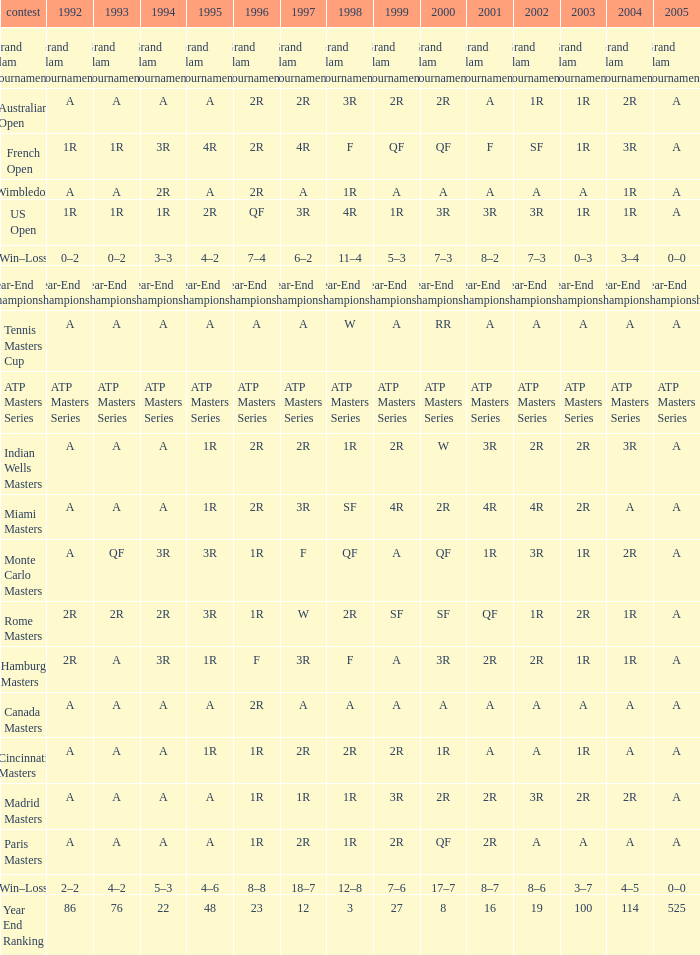Give me the full table as a dictionary. {'header': ['contest', '1992', '1993', '1994', '1995', '1996', '1997', '1998', '1999', '2000', '2001', '2002', '2003', '2004', '2005'], 'rows': [['Grand Slam Tournaments', 'Grand Slam Tournaments', 'Grand Slam Tournaments', 'Grand Slam Tournaments', 'Grand Slam Tournaments', 'Grand Slam Tournaments', 'Grand Slam Tournaments', 'Grand Slam Tournaments', 'Grand Slam Tournaments', 'Grand Slam Tournaments', 'Grand Slam Tournaments', 'Grand Slam Tournaments', 'Grand Slam Tournaments', 'Grand Slam Tournaments', 'Grand Slam Tournaments'], ['Australian Open', 'A', 'A', 'A', 'A', '2R', '2R', '3R', '2R', '2R', 'A', '1R', '1R', '2R', 'A'], ['French Open', '1R', '1R', '3R', '4R', '2R', '4R', 'F', 'QF', 'QF', 'F', 'SF', '1R', '3R', 'A'], ['Wimbledon', 'A', 'A', '2R', 'A', '2R', 'A', '1R', 'A', 'A', 'A', 'A', 'A', '1R', 'A'], ['US Open', '1R', '1R', '1R', '2R', 'QF', '3R', '4R', '1R', '3R', '3R', '3R', '1R', '1R', 'A'], ['Win–Loss', '0–2', '0–2', '3–3', '4–2', '7–4', '6–2', '11–4', '5–3', '7–3', '8–2', '7–3', '0–3', '3–4', '0–0'], ['Year-End Championship', 'Year-End Championship', 'Year-End Championship', 'Year-End Championship', 'Year-End Championship', 'Year-End Championship', 'Year-End Championship', 'Year-End Championship', 'Year-End Championship', 'Year-End Championship', 'Year-End Championship', 'Year-End Championship', 'Year-End Championship', 'Year-End Championship', 'Year-End Championship'], ['Tennis Masters Cup', 'A', 'A', 'A', 'A', 'A', 'A', 'W', 'A', 'RR', 'A', 'A', 'A', 'A', 'A'], ['ATP Masters Series', 'ATP Masters Series', 'ATP Masters Series', 'ATP Masters Series', 'ATP Masters Series', 'ATP Masters Series', 'ATP Masters Series', 'ATP Masters Series', 'ATP Masters Series', 'ATP Masters Series', 'ATP Masters Series', 'ATP Masters Series', 'ATP Masters Series', 'ATP Masters Series', 'ATP Masters Series'], ['Indian Wells Masters', 'A', 'A', 'A', '1R', '2R', '2R', '1R', '2R', 'W', '3R', '2R', '2R', '3R', 'A'], ['Miami Masters', 'A', 'A', 'A', '1R', '2R', '3R', 'SF', '4R', '2R', '4R', '4R', '2R', 'A', 'A'], ['Monte Carlo Masters', 'A', 'QF', '3R', '3R', '1R', 'F', 'QF', 'A', 'QF', '1R', '3R', '1R', '2R', 'A'], ['Rome Masters', '2R', '2R', '2R', '3R', '1R', 'W', '2R', 'SF', 'SF', 'QF', '1R', '2R', '1R', 'A'], ['Hamburg Masters', '2R', 'A', '3R', '1R', 'F', '3R', 'F', 'A', '3R', '2R', '2R', '1R', '1R', 'A'], ['Canada Masters', 'A', 'A', 'A', 'A', '2R', 'A', 'A', 'A', 'A', 'A', 'A', 'A', 'A', 'A'], ['Cincinnati Masters', 'A', 'A', 'A', '1R', '1R', '2R', '2R', '2R', '1R', 'A', 'A', '1R', 'A', 'A'], ['Madrid Masters', 'A', 'A', 'A', 'A', '1R', '1R', '1R', '3R', '2R', '2R', '3R', '2R', '2R', 'A'], ['Paris Masters', 'A', 'A', 'A', 'A', '1R', '2R', '1R', '2R', 'QF', '2R', 'A', 'A', 'A', 'A'], ['Win–Loss', '2–2', '4–2', '5–3', '4–6', '8–8', '18–7', '12–8', '7–6', '17–7', '8–7', '8–6', '3–7', '4–5', '0–0'], ['Year End Ranking', '86', '76', '22', '48', '23', '12', '3', '27', '8', '16', '19', '100', '114', '525']]} What is Tournament, when 2000 is "A"? Wimbledon, Canada Masters. 